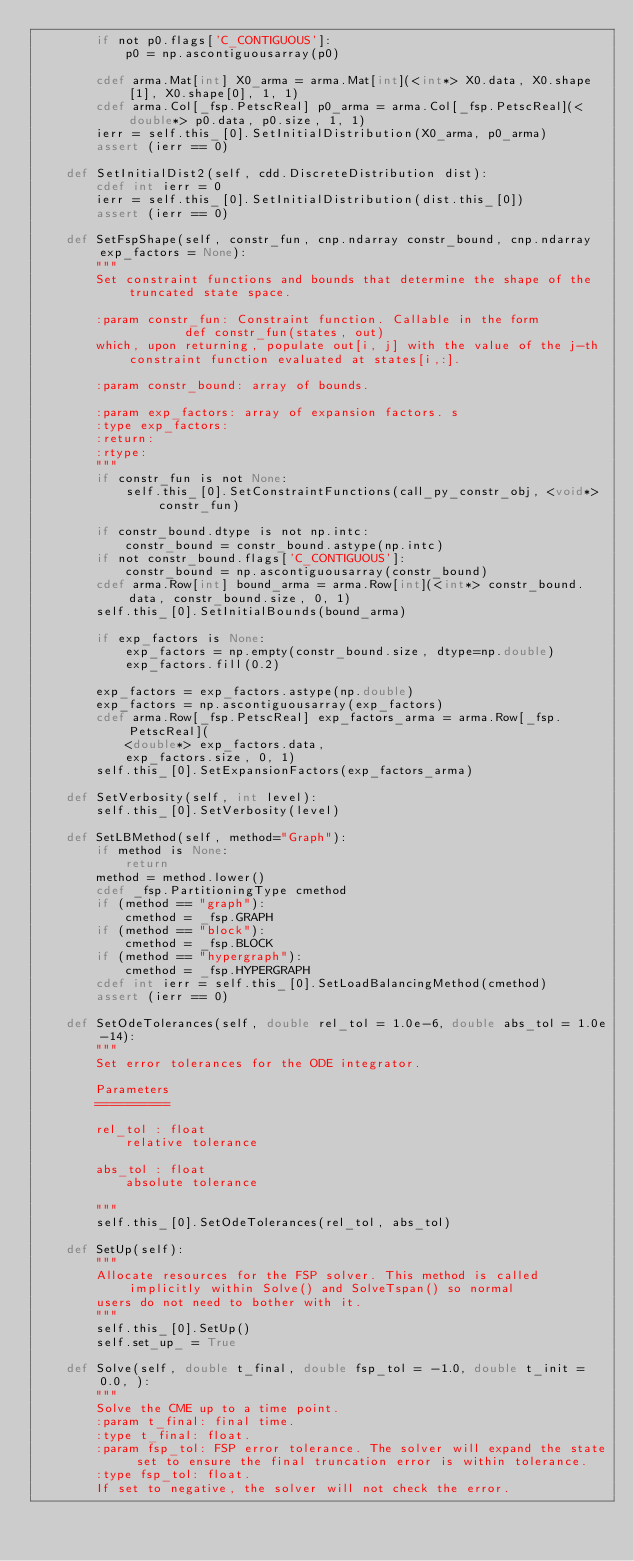Convert code to text. <code><loc_0><loc_0><loc_500><loc_500><_Cython_>        if not p0.flags['C_CONTIGUOUS']:
            p0 = np.ascontiguousarray(p0)

        cdef arma.Mat[int] X0_arma = arma.Mat[int](<int*> X0.data, X0.shape[1], X0.shape[0], 1, 1)
        cdef arma.Col[_fsp.PetscReal] p0_arma = arma.Col[_fsp.PetscReal](<double*> p0.data, p0.size, 1, 1)
        ierr = self.this_[0].SetInitialDistribution(X0_arma, p0_arma)
        assert (ierr == 0)

    def SetInitialDist2(self, cdd.DiscreteDistribution dist):
        cdef int ierr = 0
        ierr = self.this_[0].SetInitialDistribution(dist.this_[0])
        assert (ierr == 0)

    def SetFspShape(self, constr_fun, cnp.ndarray constr_bound, cnp.ndarray exp_factors = None):
        """
        Set constraint functions and bounds that determine the shape of the truncated state space.

        :param constr_fun: Constraint function. Callable in the form
                    def constr_fun(states, out)
        which, upon returning, populate out[i, j] with the value of the j-th constraint function evaluated at states[i,:].

        :param constr_bound: array of bounds.

        :param exp_factors: array of expansion factors. s
        :type exp_factors:
        :return:
        :rtype:
        """
        if constr_fun is not None:
            self.this_[0].SetConstraintFunctions(call_py_constr_obj, <void*> constr_fun)

        if constr_bound.dtype is not np.intc:
            constr_bound = constr_bound.astype(np.intc)
        if not constr_bound.flags['C_CONTIGUOUS']:
            constr_bound = np.ascontiguousarray(constr_bound)
        cdef arma.Row[int] bound_arma = arma.Row[int](<int*> constr_bound.data, constr_bound.size, 0, 1)
        self.this_[0].SetInitialBounds(bound_arma)

        if exp_factors is None:
            exp_factors = np.empty(constr_bound.size, dtype=np.double)
            exp_factors.fill(0.2)

        exp_factors = exp_factors.astype(np.double)
        exp_factors = np.ascontiguousarray(exp_factors)
        cdef arma.Row[_fsp.PetscReal] exp_factors_arma = arma.Row[_fsp.PetscReal](
            <double*> exp_factors.data,
            exp_factors.size, 0, 1)
        self.this_[0].SetExpansionFactors(exp_factors_arma)

    def SetVerbosity(self, int level):
        self.this_[0].SetVerbosity(level)

    def SetLBMethod(self, method="Graph"):
        if method is None:
            return
        method = method.lower()
        cdef _fsp.PartitioningType cmethod
        if (method == "graph"):
            cmethod = _fsp.GRAPH
        if (method == "block"):
            cmethod = _fsp.BLOCK
        if (method == "hypergraph"):
            cmethod = _fsp.HYPERGRAPH
        cdef int ierr = self.this_[0].SetLoadBalancingMethod(cmethod)
        assert (ierr == 0)

    def SetOdeTolerances(self, double rel_tol = 1.0e-6, double abs_tol = 1.0e-14):
        """
        Set error tolerances for the ODE integrator.

        Parameters
        ==========

        rel_tol : float
            relative tolerance

        abs_tol : float
            absolute tolerance

        """
        self.this_[0].SetOdeTolerances(rel_tol, abs_tol)

    def SetUp(self):
        """
        Allocate resources for the FSP solver. This method is called implicitly within Solve() and SolveTspan() so normal
        users do not need to bother with it.
        """
        self.this_[0].SetUp()
        self.set_up_ = True

    def Solve(self, double t_final, double fsp_tol = -1.0, double t_init = 0.0, ):
        """
        Solve the CME up to a time point.
        :param t_final: final time.
        :type t_final: float.
        :param fsp_tol: FSP error tolerance. The solver will expand the state set to ensure the final truncation error is within tolerance.
        :type fsp_tol: float.
        If set to negative, the solver will not check the error.</code> 